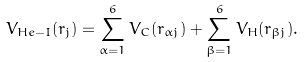Convert formula to latex. <formula><loc_0><loc_0><loc_500><loc_500>V _ { H e - I } ( r _ { j } ) = \sum _ { \alpha = 1 } ^ { 6 } V _ { C } ( r _ { \alpha j } ) + \sum _ { \beta = 1 } ^ { 6 } V _ { H } ( r _ { \beta j } ) .</formula> 